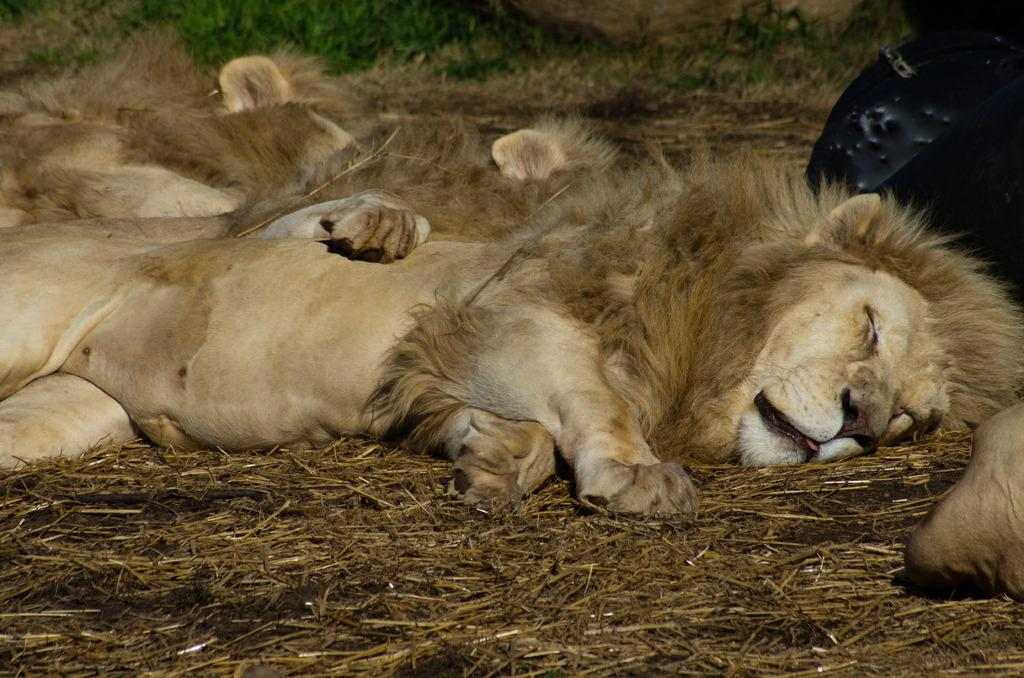What animals can be seen in the image? There are lions sleeping in the image. What type of vegetation is present in the foreground of the image? There is dry grass in the foreground of the image. What type of vegetation is present in the background of the image? There is grass visible in the background of the image. What color is the object on the right side of the image? There is a black color object on the right side of the image. How many spiders can be seen crawling on the lions in the image? There are no spiders visible in the image; it features lions sleeping. What is the level of noise in the image? The image does not provide any information about the level of noise, as it is a still image. 